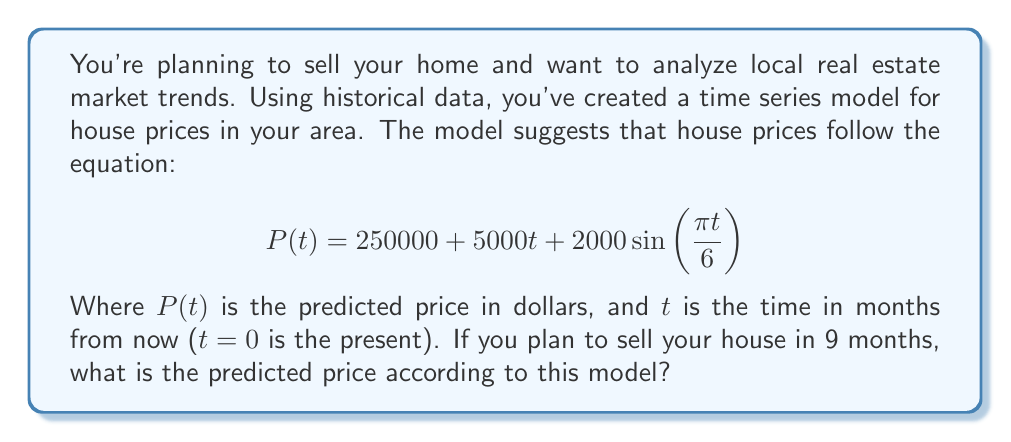Give your solution to this math problem. To solve this problem, we need to follow these steps:

1. Understand the given equation:
   $$P(t) = 250000 + 5000t + 2000\sin(\frac{\pi t}{6})$$
   Where:
   - $P(t)$ is the predicted price in dollars
   - $t$ is the time in months from now
   - 250000 is the base price
   - 5000t represents a linear increase over time
   - $2000\sin(\frac{\pi t}{6})$ represents a seasonal fluctuation

2. We want to find the price after 9 months, so we need to substitute t=9 into the equation:
   $$P(9) = 250000 + 5000(9) + 2000\sin(\frac{\pi (9)}{6})$$

3. Let's calculate each part:
   - 250000 remains as is
   - $5000(9) = 45000$
   - For the sine term: $\sin(\frac{\pi (9)}{6}) = \sin(\frac{3\pi}{2}) = -1$

4. Now we can simplify:
   $$P(9) = 250000 + 45000 + 2000(-1)$$
   $$P(9) = 250000 + 45000 - 2000$$

5. Finally, we can compute the result:
   $$P(9) = 293000$$

Therefore, according to this model, the predicted price of your house in 9 months would be $293,000.
Answer: $293,000 